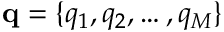<formula> <loc_0><loc_0><loc_500><loc_500>q = \{ q _ { 1 } , q _ { 2 } , \dots , q _ { M } \}</formula> 